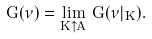Convert formula to latex. <formula><loc_0><loc_0><loc_500><loc_500>G ( \nu ) = \lim _ { K \uparrow A } \, G ( \nu | _ { K } ) .</formula> 